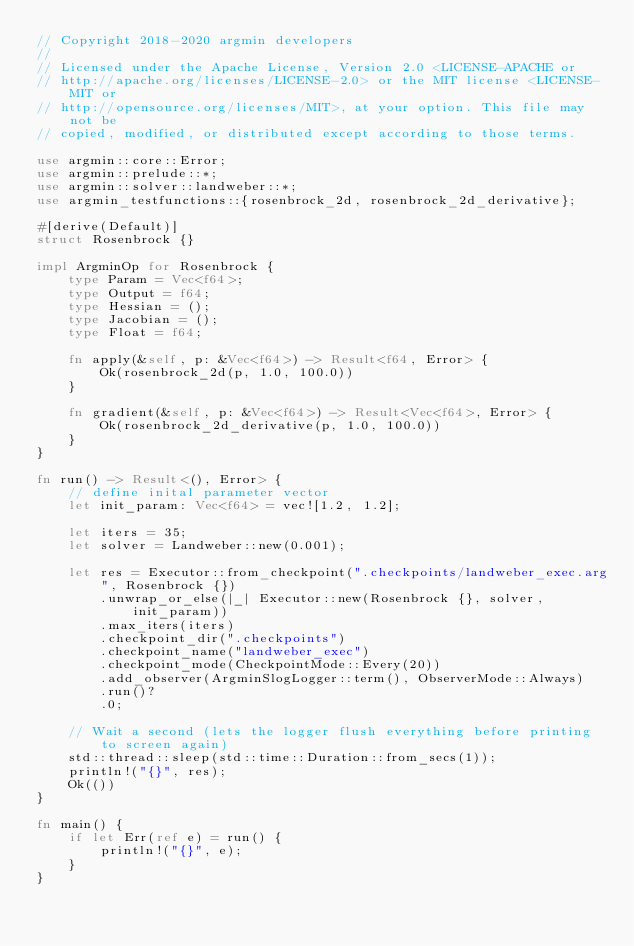Convert code to text. <code><loc_0><loc_0><loc_500><loc_500><_Rust_>// Copyright 2018-2020 argmin developers
//
// Licensed under the Apache License, Version 2.0 <LICENSE-APACHE or
// http://apache.org/licenses/LICENSE-2.0> or the MIT license <LICENSE-MIT or
// http://opensource.org/licenses/MIT>, at your option. This file may not be
// copied, modified, or distributed except according to those terms.

use argmin::core::Error;
use argmin::prelude::*;
use argmin::solver::landweber::*;
use argmin_testfunctions::{rosenbrock_2d, rosenbrock_2d_derivative};

#[derive(Default)]
struct Rosenbrock {}

impl ArgminOp for Rosenbrock {
    type Param = Vec<f64>;
    type Output = f64;
    type Hessian = ();
    type Jacobian = ();
    type Float = f64;

    fn apply(&self, p: &Vec<f64>) -> Result<f64, Error> {
        Ok(rosenbrock_2d(p, 1.0, 100.0))
    }

    fn gradient(&self, p: &Vec<f64>) -> Result<Vec<f64>, Error> {
        Ok(rosenbrock_2d_derivative(p, 1.0, 100.0))
    }
}

fn run() -> Result<(), Error> {
    // define inital parameter vector
    let init_param: Vec<f64> = vec![1.2, 1.2];

    let iters = 35;
    let solver = Landweber::new(0.001);

    let res = Executor::from_checkpoint(".checkpoints/landweber_exec.arg", Rosenbrock {})
        .unwrap_or_else(|_| Executor::new(Rosenbrock {}, solver, init_param))
        .max_iters(iters)
        .checkpoint_dir(".checkpoints")
        .checkpoint_name("landweber_exec")
        .checkpoint_mode(CheckpointMode::Every(20))
        .add_observer(ArgminSlogLogger::term(), ObserverMode::Always)
        .run()?
        .0;

    // Wait a second (lets the logger flush everything before printing to screen again)
    std::thread::sleep(std::time::Duration::from_secs(1));
    println!("{}", res);
    Ok(())
}

fn main() {
    if let Err(ref e) = run() {
        println!("{}", e);
    }
}
</code> 